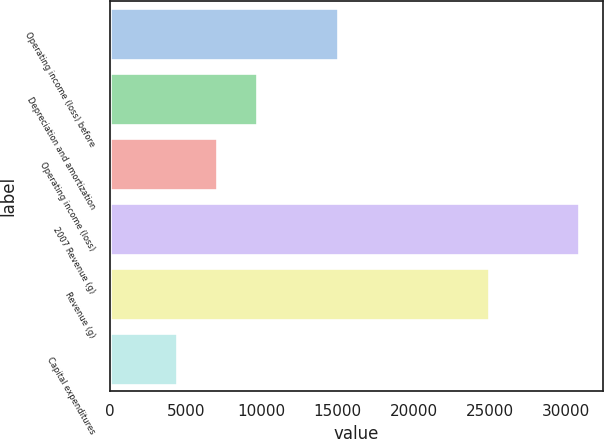<chart> <loc_0><loc_0><loc_500><loc_500><bar_chart><fcel>Operating income (loss) before<fcel>Depreciation and amortization<fcel>Operating income (loss)<fcel>2007 Revenue (g)<fcel>Revenue (g)<fcel>Capital expenditures<nl><fcel>14995<fcel>9695<fcel>7045<fcel>30895<fcel>24966<fcel>4395<nl></chart> 